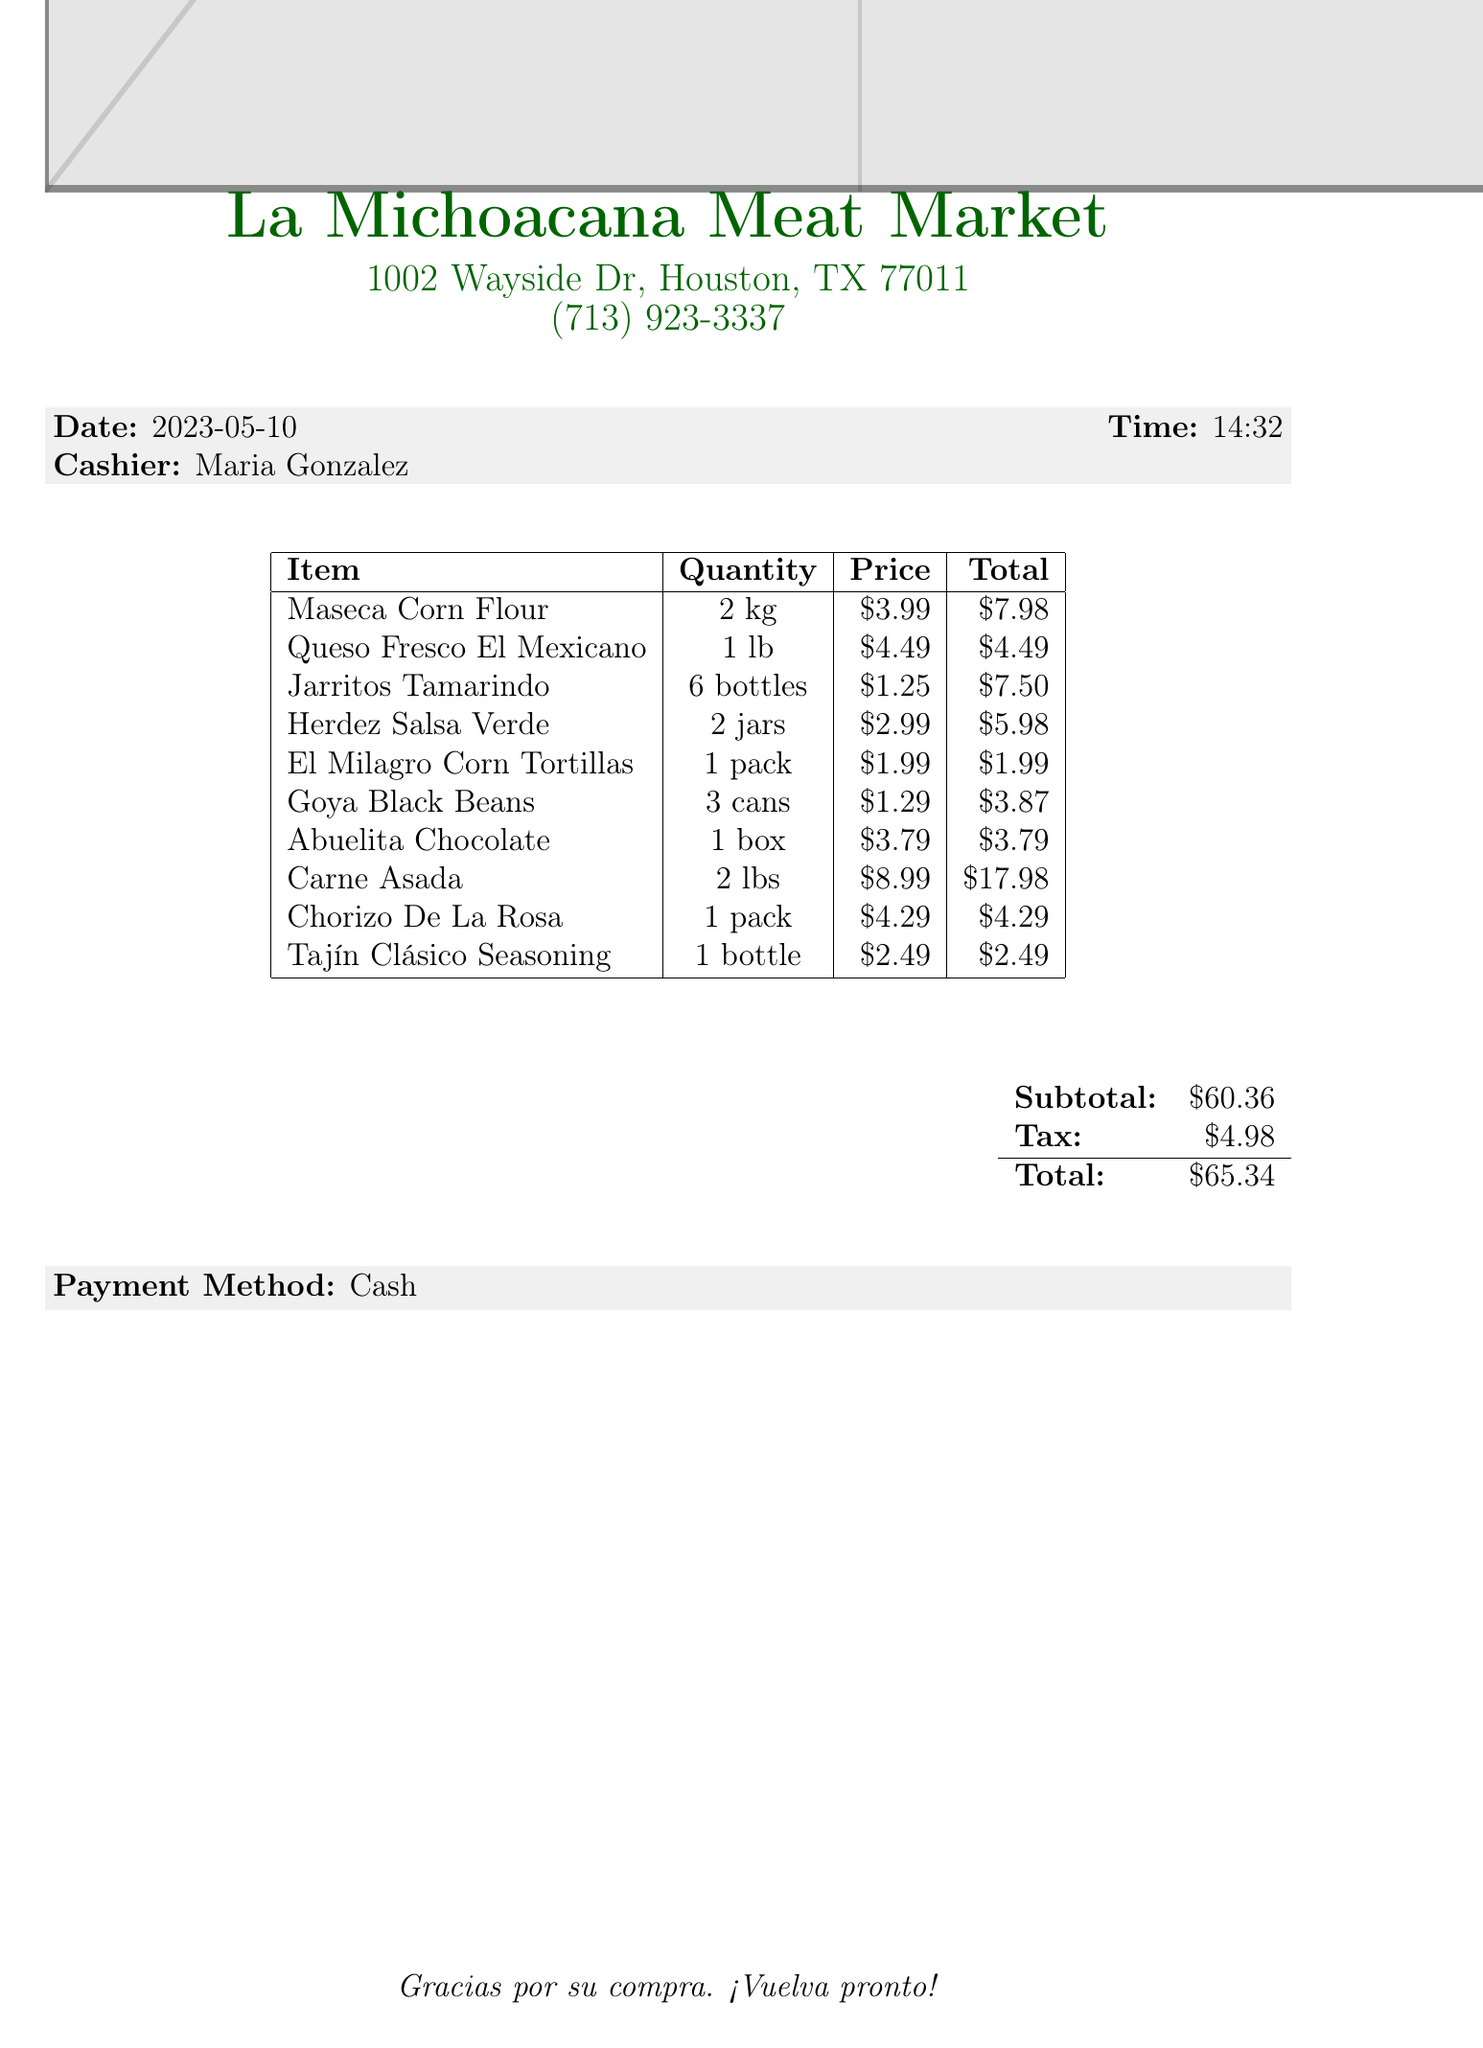What is the name of the store? The store name is mentioned at the top of the document, which is La Michoacana Meat Market.
Answer: La Michoacana Meat Market What is the total amount? The total amount is calculated at the bottom of the invoice, including subtotal and tax, which is $65.34.
Answer: $65.34 Who was the cashier? The cashier's name is provided in the document, it is listed as Maria Gonzalez.
Answer: Maria Gonzalez How many jars of Herdez Salsa Verde were purchased? The number of jars for Herdez Salsa Verde is specified in the quantity column for that item, which is 2 jars.
Answer: 2 jars What was the price of Maseca Corn Flour? The price of Maseca Corn Flour can be found in the price column corresponding to that item, which is $3.99.
Answer: $3.99 What types of beans were bought? The document specifies the type of beans purchased under the item name, which is Goya Black Beans.
Answer: Goya Black Beans What is the quantity of Jarritos Tamarindo? The quantity of Jarritos Tamarindo is found in the quantity column for that item, which is 6 bottles.
Answer: 6 bottles What payment method was used? The payment method is provided at the bottom of the invoice and is noted to be Cash.
Answer: Cash What is the subtotal before tax? The subtotal is provided in the document as part of the total summary and is noted to be $60.36.
Answer: $60.36 